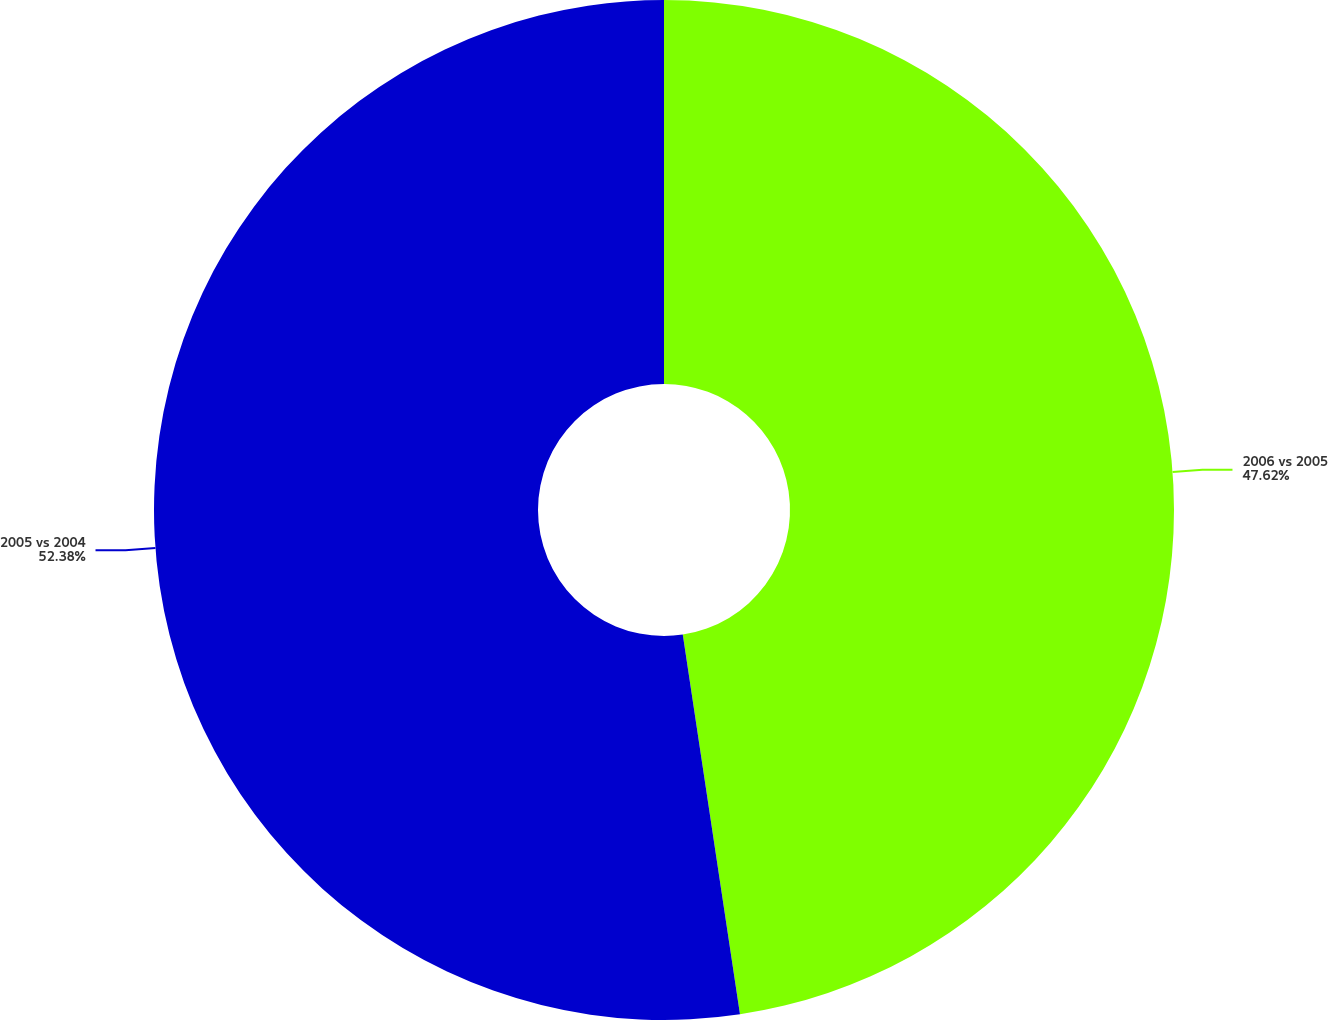Convert chart to OTSL. <chart><loc_0><loc_0><loc_500><loc_500><pie_chart><fcel>2006 vs 2005<fcel>2005 vs 2004<nl><fcel>47.62%<fcel>52.38%<nl></chart> 